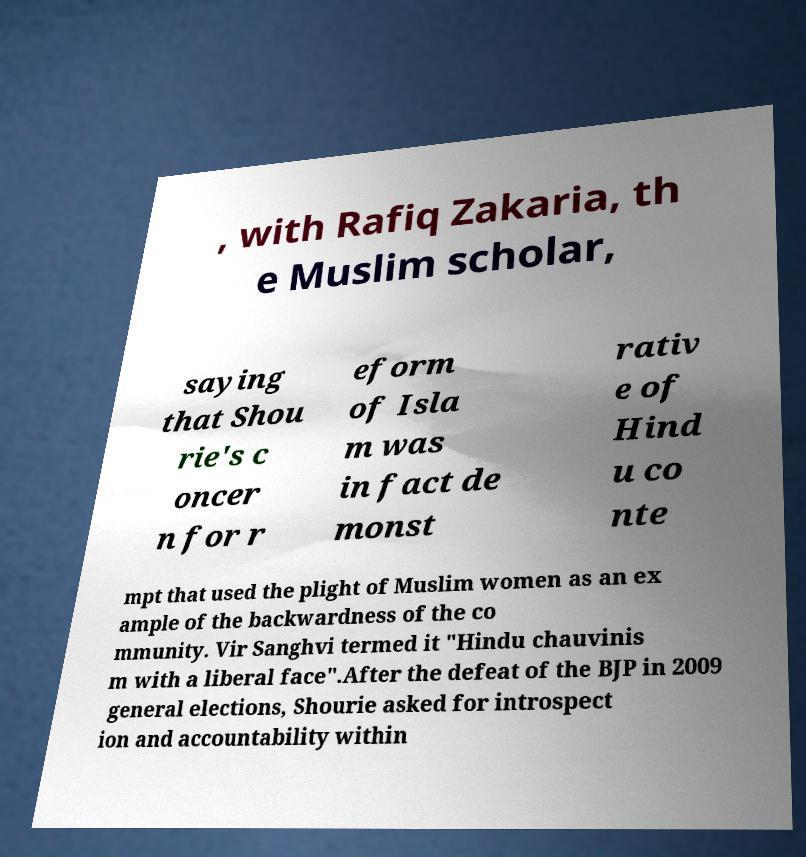Can you accurately transcribe the text from the provided image for me? , with Rafiq Zakaria, th e Muslim scholar, saying that Shou rie's c oncer n for r eform of Isla m was in fact de monst rativ e of Hind u co nte mpt that used the plight of Muslim women as an ex ample of the backwardness of the co mmunity. Vir Sanghvi termed it "Hindu chauvinis m with a liberal face".After the defeat of the BJP in 2009 general elections, Shourie asked for introspect ion and accountability within 